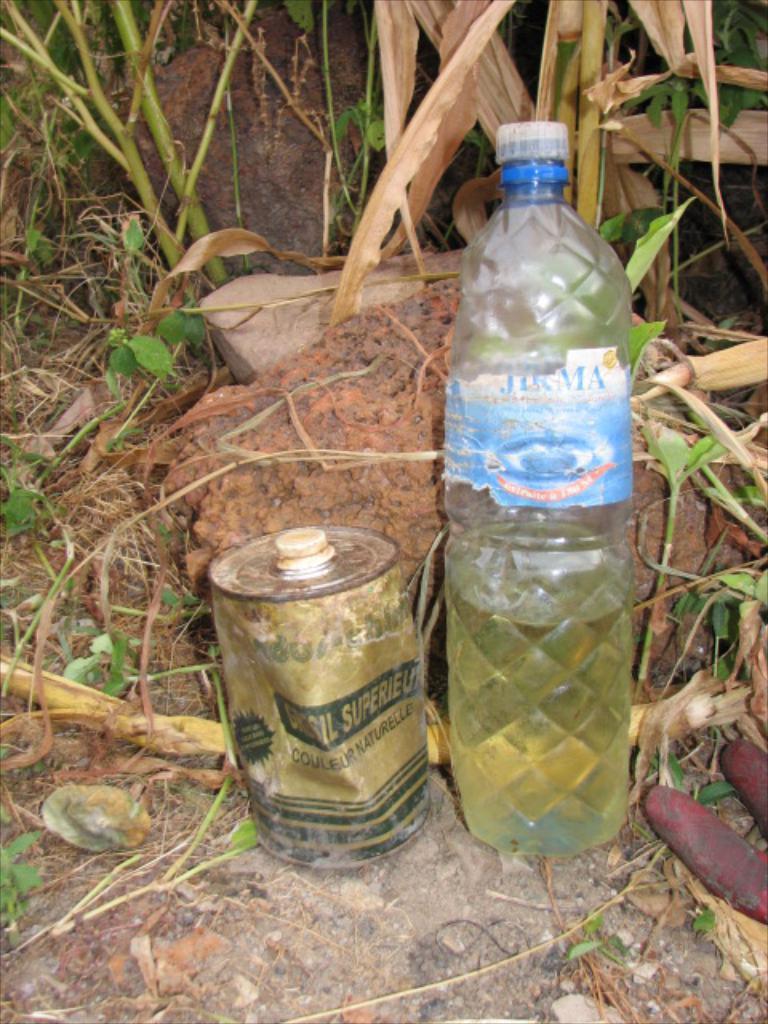Please provide a concise description of this image. In this picture does a water bottle and a can and in the backdrop, there is a rock and some plants 